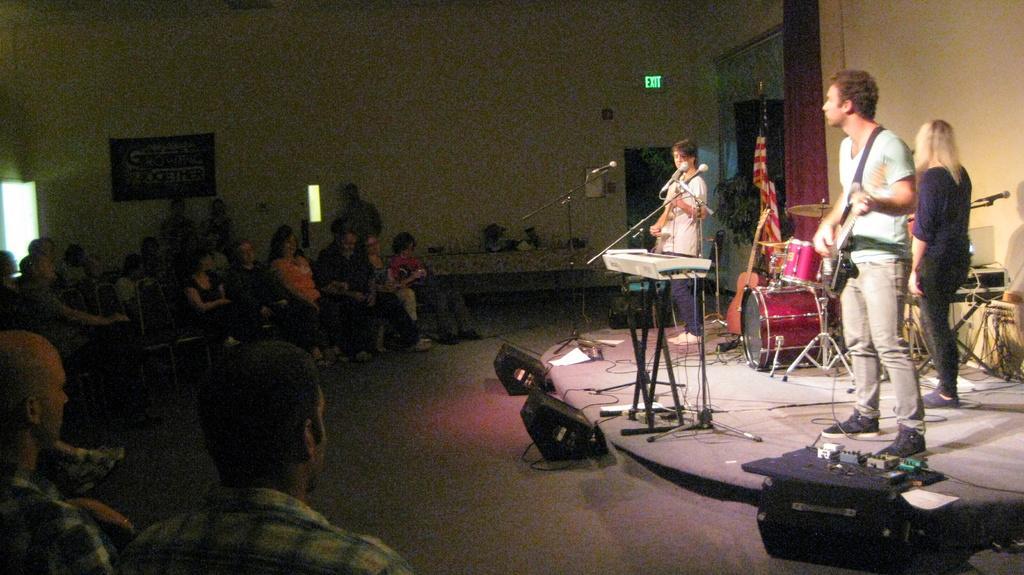Can you describe this image briefly? In this image I can see three people. I can see two people are playing the musical instruments and standing in-front of the mics. To the side of these people I can see the drum set and the flag. To the left I can see the group of people sitting on the chairs and I can see few people are standing. In the background I can see the boards to the wall. 